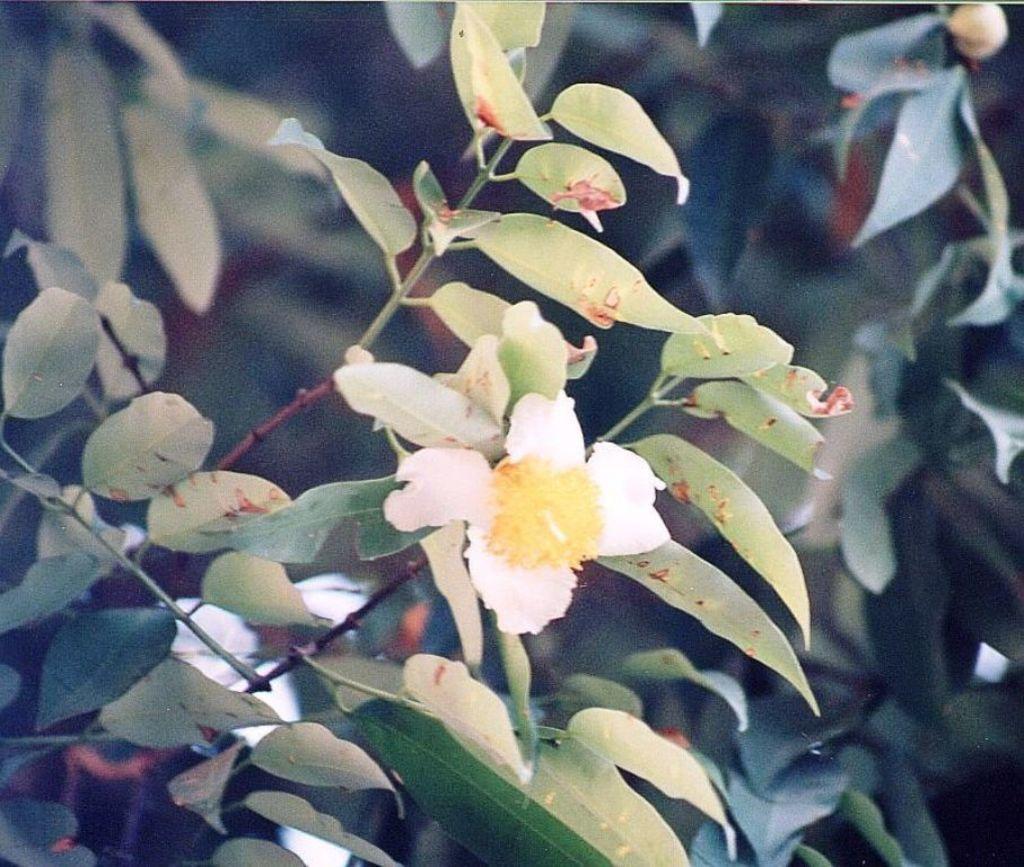Can you describe this image briefly? In this picture we can see a beautiful white color flower in the image. Behind we can see many green Leafs. 